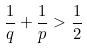<formula> <loc_0><loc_0><loc_500><loc_500>\frac { 1 } { q } + \frac { 1 } { p } > \frac { 1 } { 2 }</formula> 